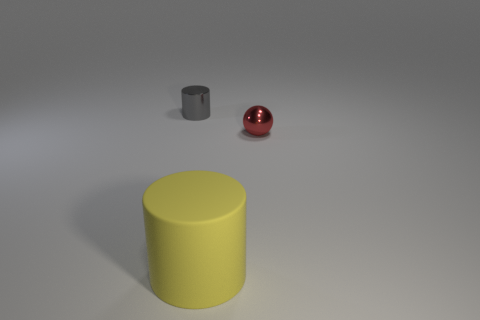Are there any other things that have the same size as the matte cylinder?
Provide a succinct answer. No. Is there anything else that has the same material as the large yellow cylinder?
Make the answer very short. No. What shape is the object that is both right of the tiny gray shiny cylinder and behind the large matte thing?
Your response must be concise. Sphere. Do the yellow object and the metal thing behind the red metallic ball have the same shape?
Offer a very short reply. Yes. Are there any tiny red objects in front of the yellow matte cylinder?
Your answer should be compact. No. How many cylinders are yellow matte objects or yellow shiny objects?
Offer a terse response. 1. Is the big yellow thing the same shape as the small gray thing?
Give a very brief answer. Yes. There is a cylinder on the right side of the tiny gray metal object; what is its size?
Your answer should be very brief. Large. There is a object that is behind the shiny sphere; is it the same size as the red sphere?
Provide a succinct answer. Yes. What is the color of the large thing?
Your response must be concise. Yellow. 